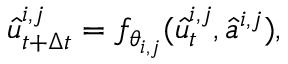Convert formula to latex. <formula><loc_0><loc_0><loc_500><loc_500>\hat { u } _ { t + \Delta t } ^ { i , j } = f _ { \theta _ { i , j } } ( \hat { u } _ { t } ^ { i , j } , \hat { a } ^ { i , j } ) ,</formula> 